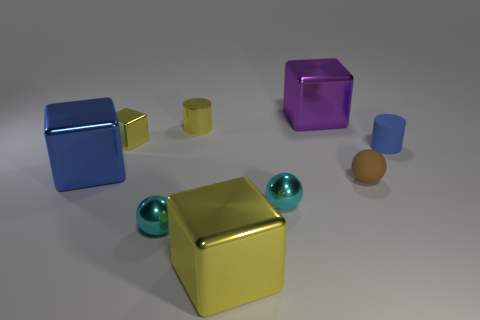There is a tiny thing that is the same shape as the large blue shiny thing; what color is it?
Your response must be concise. Yellow. What is the shape of the large purple object?
Provide a succinct answer. Cube. How many objects are big brown rubber cubes or tiny rubber objects?
Offer a very short reply. 2. There is a big object that is right of the large yellow object; is it the same color as the small matte cylinder that is to the right of the tiny shiny block?
Your answer should be very brief. No. What number of other objects are the same shape as the small blue rubber object?
Your answer should be compact. 1. Are there any cyan shiny objects?
Your answer should be compact. Yes. How many things are matte spheres or metallic balls left of the yellow metal cylinder?
Offer a terse response. 2. Do the blue thing right of the purple shiny thing and the yellow metal cylinder have the same size?
Provide a short and direct response. Yes. How many other things are there of the same size as the blue metal block?
Your response must be concise. 2. What is the color of the matte sphere?
Make the answer very short. Brown. 